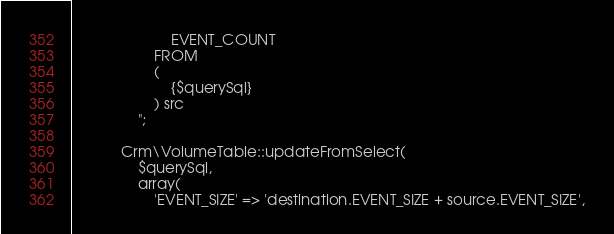<code> <loc_0><loc_0><loc_500><loc_500><_PHP_>						EVENT_COUNT
					FROM 
					(
						{$querySql}
					) src
				";

			Crm\VolumeTable::updateFromSelect(
				$querySql,
				array(
					'EVENT_SIZE' => 'destination.EVENT_SIZE + source.EVENT_SIZE',</code> 